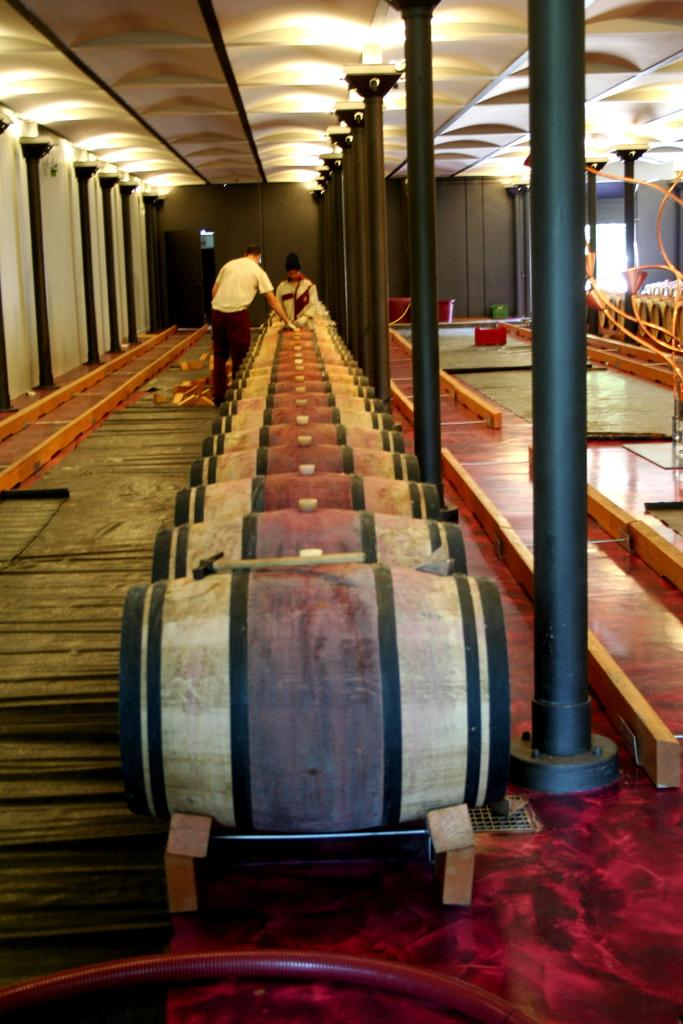What musical instruments are present in the image? There are drums in the image. What else can be seen in the image besides the drums? There are poles and lights visible in the image. Are there any people present in the image? Yes, there are people in the image. What type of apparatus is being used by the servant in the image? There is no apparatus or servant present in the image. 